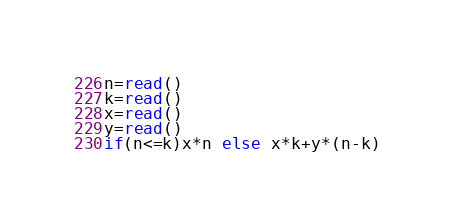Convert code to text. <code><loc_0><loc_0><loc_500><loc_500><_bc_>n=read()
k=read()
x=read()
y=read()
if(n<=k)x*n else x*k+y*(n-k)
</code> 